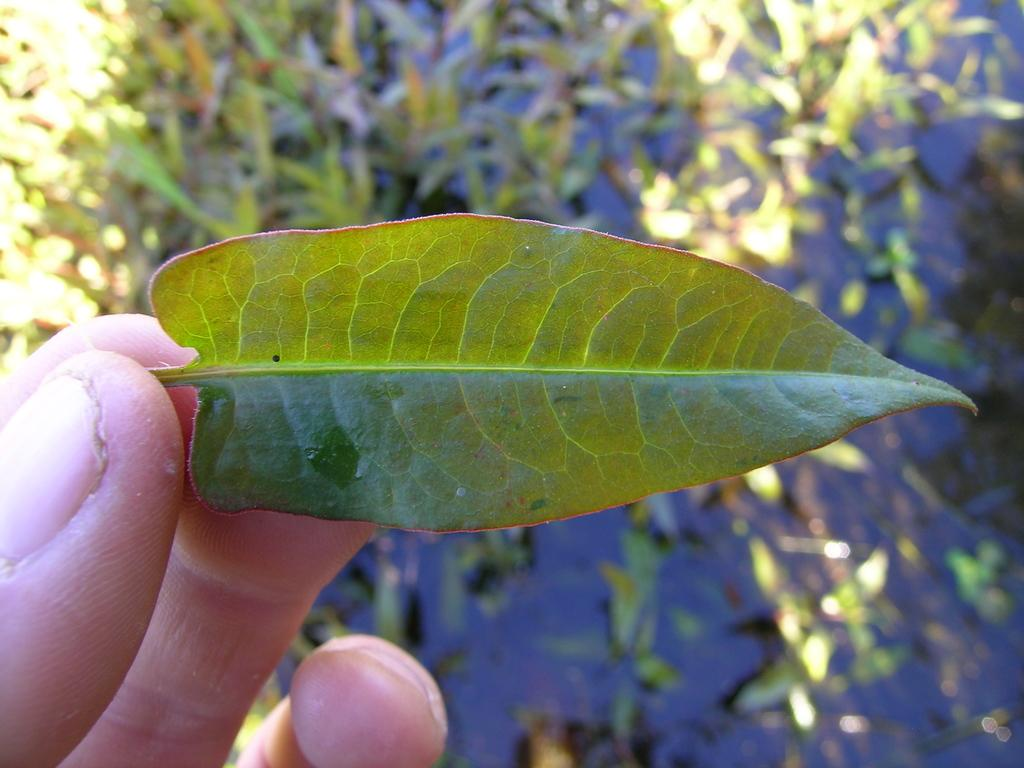What is the person's hand holding in the image? The person's hand is holding a leaf in the image. What can be seen in the background of the image? There are plants in the background of the image. What type of base is being exchanged between the person and the plant in the image? There is no base or exchange between the person and the plant in the image; the person's hand is simply holding a leaf. 